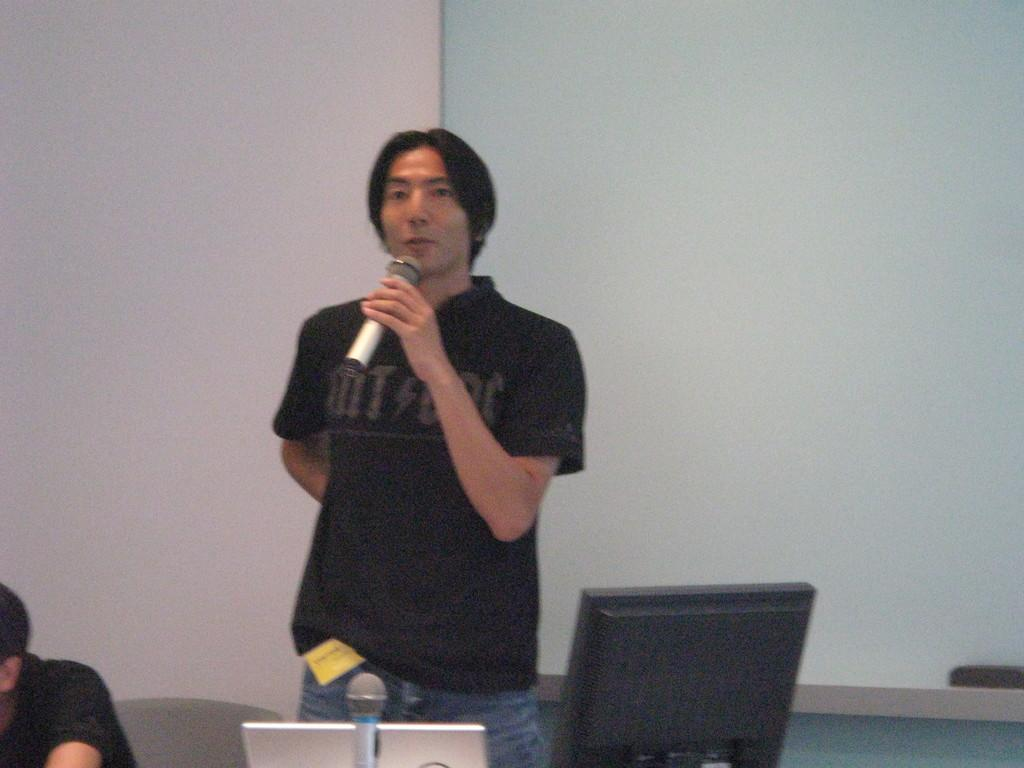What is the person in the image holding in his hand? The person is holding a microphone in his hand. What electronic device can be seen in the image? There is a laptop in the image. Can you describe the person in the image? There is a person in the image. What type of furniture is present in the image? There is a chair in the image. What is the purpose of the screen in the image? There is a screen in the image, which might be used for displaying information or visuals. What type of bird can be seen sitting on the laptop in the image? There is no bird present in the image; it only features a person holding a microphone, a laptop, a chair, and a screen. 